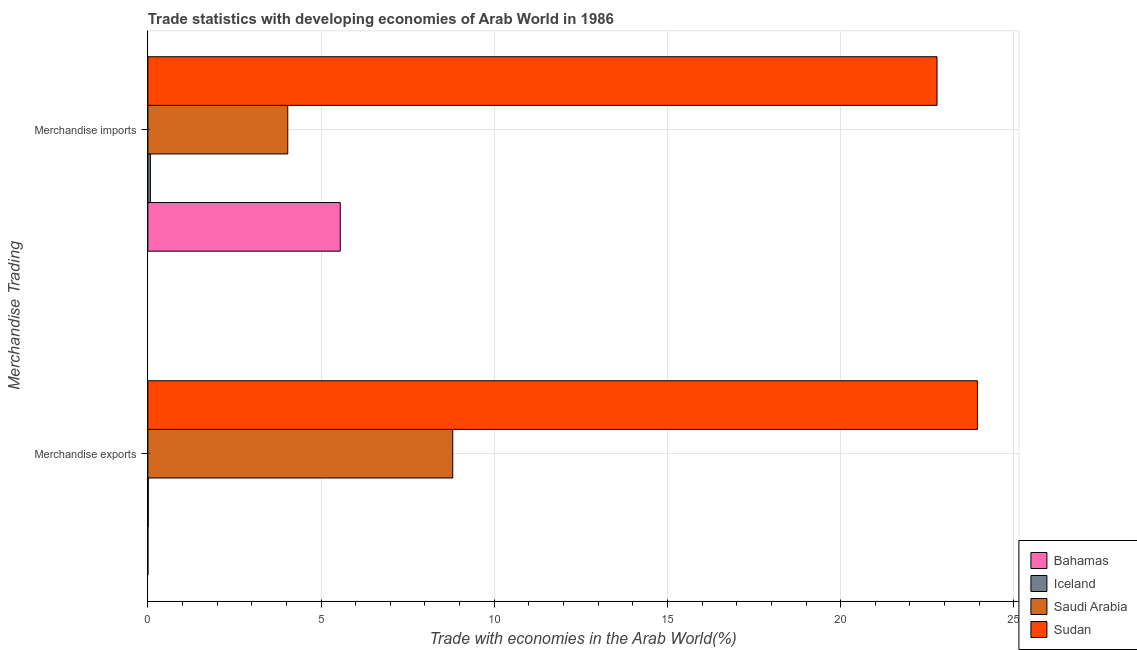How many groups of bars are there?
Offer a very short reply. 2. Are the number of bars on each tick of the Y-axis equal?
Your answer should be compact. Yes. How many bars are there on the 1st tick from the top?
Your answer should be very brief. 4. What is the label of the 1st group of bars from the top?
Make the answer very short. Merchandise imports. What is the merchandise exports in Iceland?
Provide a short and direct response. 0.01. Across all countries, what is the maximum merchandise imports?
Your answer should be compact. 22.78. Across all countries, what is the minimum merchandise imports?
Provide a short and direct response. 0.07. In which country was the merchandise imports maximum?
Your answer should be very brief. Sudan. In which country was the merchandise exports minimum?
Offer a very short reply. Bahamas. What is the total merchandise exports in the graph?
Provide a short and direct response. 32.76. What is the difference between the merchandise imports in Bahamas and that in Saudi Arabia?
Offer a terse response. 1.52. What is the difference between the merchandise exports in Bahamas and the merchandise imports in Sudan?
Keep it short and to the point. -22.78. What is the average merchandise imports per country?
Offer a very short reply. 8.11. What is the difference between the merchandise exports and merchandise imports in Saudi Arabia?
Keep it short and to the point. 4.76. What is the ratio of the merchandise exports in Bahamas to that in Saudi Arabia?
Provide a succinct answer. 0. Is the merchandise imports in Bahamas less than that in Sudan?
Offer a terse response. Yes. In how many countries, is the merchandise exports greater than the average merchandise exports taken over all countries?
Offer a terse response. 2. What does the 3rd bar from the top in Merchandise exports represents?
Offer a very short reply. Iceland. What does the 3rd bar from the bottom in Merchandise exports represents?
Keep it short and to the point. Saudi Arabia. How many bars are there?
Provide a short and direct response. 8. How many countries are there in the graph?
Your response must be concise. 4. Does the graph contain any zero values?
Keep it short and to the point. No. Does the graph contain grids?
Ensure brevity in your answer.  Yes. Where does the legend appear in the graph?
Provide a short and direct response. Bottom right. How many legend labels are there?
Provide a succinct answer. 4. How are the legend labels stacked?
Make the answer very short. Vertical. What is the title of the graph?
Make the answer very short. Trade statistics with developing economies of Arab World in 1986. Does "St. Martin (French part)" appear as one of the legend labels in the graph?
Give a very brief answer. No. What is the label or title of the X-axis?
Provide a succinct answer. Trade with economies in the Arab World(%). What is the label or title of the Y-axis?
Provide a short and direct response. Merchandise Trading. What is the Trade with economies in the Arab World(%) of Bahamas in Merchandise exports?
Offer a terse response. 0. What is the Trade with economies in the Arab World(%) of Iceland in Merchandise exports?
Provide a short and direct response. 0.01. What is the Trade with economies in the Arab World(%) of Saudi Arabia in Merchandise exports?
Your response must be concise. 8.8. What is the Trade with economies in the Arab World(%) in Sudan in Merchandise exports?
Make the answer very short. 23.95. What is the Trade with economies in the Arab World(%) of Bahamas in Merchandise imports?
Give a very brief answer. 5.55. What is the Trade with economies in the Arab World(%) of Iceland in Merchandise imports?
Your answer should be very brief. 0.07. What is the Trade with economies in the Arab World(%) in Saudi Arabia in Merchandise imports?
Offer a terse response. 4.04. What is the Trade with economies in the Arab World(%) in Sudan in Merchandise imports?
Make the answer very short. 22.78. Across all Merchandise Trading, what is the maximum Trade with economies in the Arab World(%) in Bahamas?
Provide a short and direct response. 5.55. Across all Merchandise Trading, what is the maximum Trade with economies in the Arab World(%) of Iceland?
Provide a short and direct response. 0.07. Across all Merchandise Trading, what is the maximum Trade with economies in the Arab World(%) in Saudi Arabia?
Provide a succinct answer. 8.8. Across all Merchandise Trading, what is the maximum Trade with economies in the Arab World(%) of Sudan?
Give a very brief answer. 23.95. Across all Merchandise Trading, what is the minimum Trade with economies in the Arab World(%) of Bahamas?
Your answer should be very brief. 0. Across all Merchandise Trading, what is the minimum Trade with economies in the Arab World(%) in Iceland?
Make the answer very short. 0.01. Across all Merchandise Trading, what is the minimum Trade with economies in the Arab World(%) of Saudi Arabia?
Ensure brevity in your answer.  4.04. Across all Merchandise Trading, what is the minimum Trade with economies in the Arab World(%) of Sudan?
Offer a terse response. 22.78. What is the total Trade with economies in the Arab World(%) of Bahamas in the graph?
Give a very brief answer. 5.56. What is the total Trade with economies in the Arab World(%) of Iceland in the graph?
Make the answer very short. 0.08. What is the total Trade with economies in the Arab World(%) in Saudi Arabia in the graph?
Your response must be concise. 12.84. What is the total Trade with economies in the Arab World(%) in Sudan in the graph?
Give a very brief answer. 46.73. What is the difference between the Trade with economies in the Arab World(%) in Bahamas in Merchandise exports and that in Merchandise imports?
Your answer should be very brief. -5.55. What is the difference between the Trade with economies in the Arab World(%) in Iceland in Merchandise exports and that in Merchandise imports?
Your answer should be very brief. -0.06. What is the difference between the Trade with economies in the Arab World(%) in Saudi Arabia in Merchandise exports and that in Merchandise imports?
Keep it short and to the point. 4.76. What is the difference between the Trade with economies in the Arab World(%) of Sudan in Merchandise exports and that in Merchandise imports?
Your answer should be compact. 1.17. What is the difference between the Trade with economies in the Arab World(%) in Bahamas in Merchandise exports and the Trade with economies in the Arab World(%) in Iceland in Merchandise imports?
Offer a terse response. -0.07. What is the difference between the Trade with economies in the Arab World(%) of Bahamas in Merchandise exports and the Trade with economies in the Arab World(%) of Saudi Arabia in Merchandise imports?
Offer a very short reply. -4.04. What is the difference between the Trade with economies in the Arab World(%) of Bahamas in Merchandise exports and the Trade with economies in the Arab World(%) of Sudan in Merchandise imports?
Keep it short and to the point. -22.78. What is the difference between the Trade with economies in the Arab World(%) in Iceland in Merchandise exports and the Trade with economies in the Arab World(%) in Saudi Arabia in Merchandise imports?
Your answer should be very brief. -4.03. What is the difference between the Trade with economies in the Arab World(%) in Iceland in Merchandise exports and the Trade with economies in the Arab World(%) in Sudan in Merchandise imports?
Provide a short and direct response. -22.77. What is the difference between the Trade with economies in the Arab World(%) in Saudi Arabia in Merchandise exports and the Trade with economies in the Arab World(%) in Sudan in Merchandise imports?
Make the answer very short. -13.98. What is the average Trade with economies in the Arab World(%) of Bahamas per Merchandise Trading?
Give a very brief answer. 2.78. What is the average Trade with economies in the Arab World(%) in Iceland per Merchandise Trading?
Provide a short and direct response. 0.04. What is the average Trade with economies in the Arab World(%) of Saudi Arabia per Merchandise Trading?
Keep it short and to the point. 6.42. What is the average Trade with economies in the Arab World(%) in Sudan per Merchandise Trading?
Your response must be concise. 23.36. What is the difference between the Trade with economies in the Arab World(%) of Bahamas and Trade with economies in the Arab World(%) of Iceland in Merchandise exports?
Your answer should be compact. -0.01. What is the difference between the Trade with economies in the Arab World(%) of Bahamas and Trade with economies in the Arab World(%) of Saudi Arabia in Merchandise exports?
Provide a short and direct response. -8.8. What is the difference between the Trade with economies in the Arab World(%) of Bahamas and Trade with economies in the Arab World(%) of Sudan in Merchandise exports?
Ensure brevity in your answer.  -23.95. What is the difference between the Trade with economies in the Arab World(%) in Iceland and Trade with economies in the Arab World(%) in Saudi Arabia in Merchandise exports?
Make the answer very short. -8.79. What is the difference between the Trade with economies in the Arab World(%) of Iceland and Trade with economies in the Arab World(%) of Sudan in Merchandise exports?
Provide a short and direct response. -23.94. What is the difference between the Trade with economies in the Arab World(%) in Saudi Arabia and Trade with economies in the Arab World(%) in Sudan in Merchandise exports?
Make the answer very short. -15.15. What is the difference between the Trade with economies in the Arab World(%) of Bahamas and Trade with economies in the Arab World(%) of Iceland in Merchandise imports?
Keep it short and to the point. 5.48. What is the difference between the Trade with economies in the Arab World(%) in Bahamas and Trade with economies in the Arab World(%) in Saudi Arabia in Merchandise imports?
Provide a succinct answer. 1.52. What is the difference between the Trade with economies in the Arab World(%) in Bahamas and Trade with economies in the Arab World(%) in Sudan in Merchandise imports?
Offer a very short reply. -17.23. What is the difference between the Trade with economies in the Arab World(%) in Iceland and Trade with economies in the Arab World(%) in Saudi Arabia in Merchandise imports?
Your response must be concise. -3.97. What is the difference between the Trade with economies in the Arab World(%) in Iceland and Trade with economies in the Arab World(%) in Sudan in Merchandise imports?
Offer a very short reply. -22.71. What is the difference between the Trade with economies in the Arab World(%) of Saudi Arabia and Trade with economies in the Arab World(%) of Sudan in Merchandise imports?
Your answer should be very brief. -18.74. What is the ratio of the Trade with economies in the Arab World(%) in Bahamas in Merchandise exports to that in Merchandise imports?
Give a very brief answer. 0. What is the ratio of the Trade with economies in the Arab World(%) of Iceland in Merchandise exports to that in Merchandise imports?
Give a very brief answer. 0.16. What is the ratio of the Trade with economies in the Arab World(%) of Saudi Arabia in Merchandise exports to that in Merchandise imports?
Provide a succinct answer. 2.18. What is the ratio of the Trade with economies in the Arab World(%) in Sudan in Merchandise exports to that in Merchandise imports?
Offer a terse response. 1.05. What is the difference between the highest and the second highest Trade with economies in the Arab World(%) in Bahamas?
Offer a very short reply. 5.55. What is the difference between the highest and the second highest Trade with economies in the Arab World(%) in Iceland?
Make the answer very short. 0.06. What is the difference between the highest and the second highest Trade with economies in the Arab World(%) in Saudi Arabia?
Offer a very short reply. 4.76. What is the difference between the highest and the second highest Trade with economies in the Arab World(%) in Sudan?
Make the answer very short. 1.17. What is the difference between the highest and the lowest Trade with economies in the Arab World(%) in Bahamas?
Keep it short and to the point. 5.55. What is the difference between the highest and the lowest Trade with economies in the Arab World(%) in Iceland?
Your answer should be very brief. 0.06. What is the difference between the highest and the lowest Trade with economies in the Arab World(%) in Saudi Arabia?
Provide a succinct answer. 4.76. What is the difference between the highest and the lowest Trade with economies in the Arab World(%) in Sudan?
Provide a short and direct response. 1.17. 